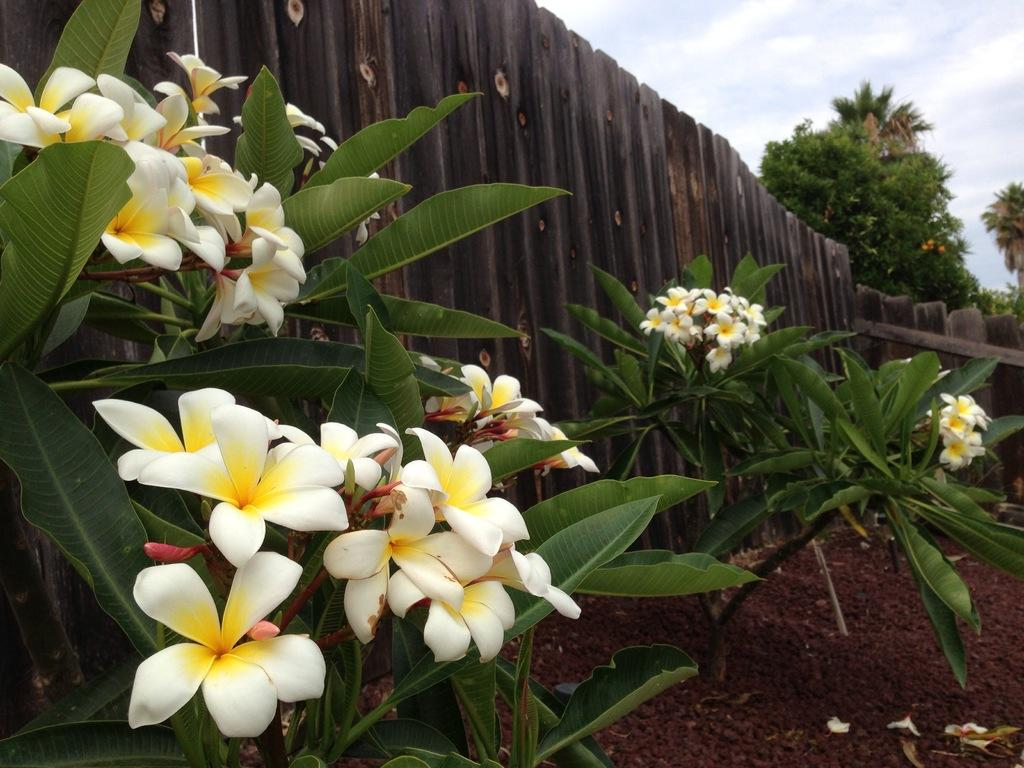What type of flora is present in the image? There are flowers in the image. What colors are the flowers? The flowers are in white and yellow colors. What can be seen in the background of the image? There is a wooden facing and trees in the background of the image. What is the color of the trees? The trees are green in color. What else is visible in the background of the image? The sky is visible in the background of the image. What is the color of the sky? The sky is white in color. What type of cracker is being baked in the oven in the image? There is no oven or cracker present in the image. What smell can be detected from the flowers in the image? The image does not provide information about the smell of the flowers, only their appearance. 